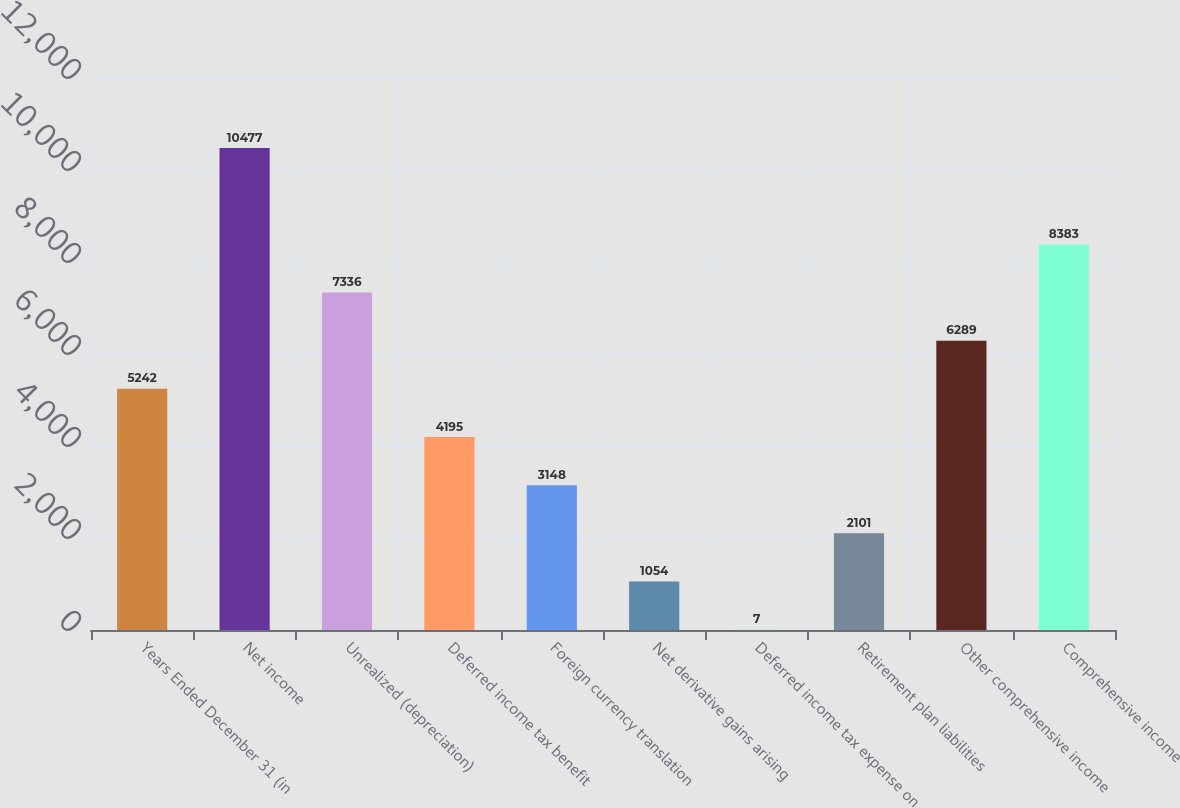<chart> <loc_0><loc_0><loc_500><loc_500><bar_chart><fcel>Years Ended December 31 (in<fcel>Net income<fcel>Unrealized (depreciation)<fcel>Deferred income tax benefit<fcel>Foreign currency translation<fcel>Net derivative gains arising<fcel>Deferred income tax expense on<fcel>Retirement plan liabilities<fcel>Other comprehensive income<fcel>Comprehensive income<nl><fcel>5242<fcel>10477<fcel>7336<fcel>4195<fcel>3148<fcel>1054<fcel>7<fcel>2101<fcel>6289<fcel>8383<nl></chart> 